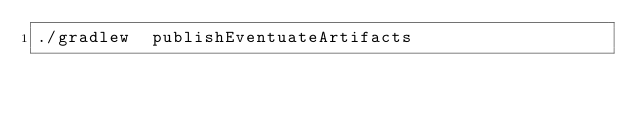Convert code to text. <code><loc_0><loc_0><loc_500><loc_500><_Bash_>./gradlew  publishEventuateArtifacts</code> 